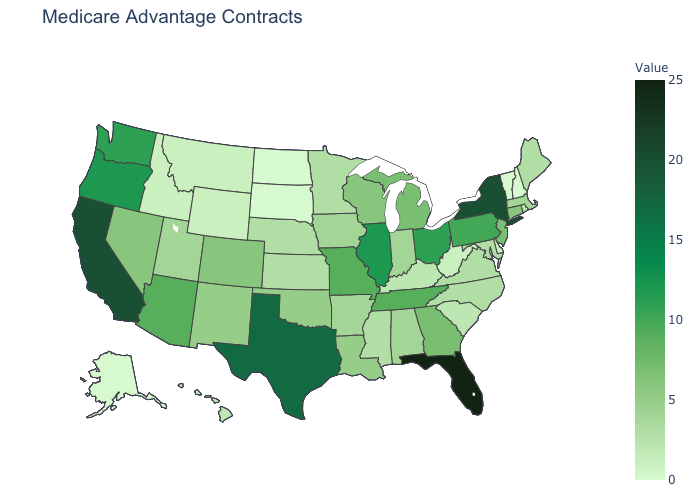Among the states that border Mississippi , which have the lowest value?
Answer briefly. Alabama, Arkansas. Is the legend a continuous bar?
Answer briefly. Yes. Which states have the highest value in the USA?
Give a very brief answer. Florida. Among the states that border Oklahoma , which have the lowest value?
Keep it brief. Kansas. Among the states that border Delaware , does Pennsylvania have the lowest value?
Answer briefly. No. Does the map have missing data?
Give a very brief answer. No. Does Rhode Island have the highest value in the USA?
Concise answer only. No. 